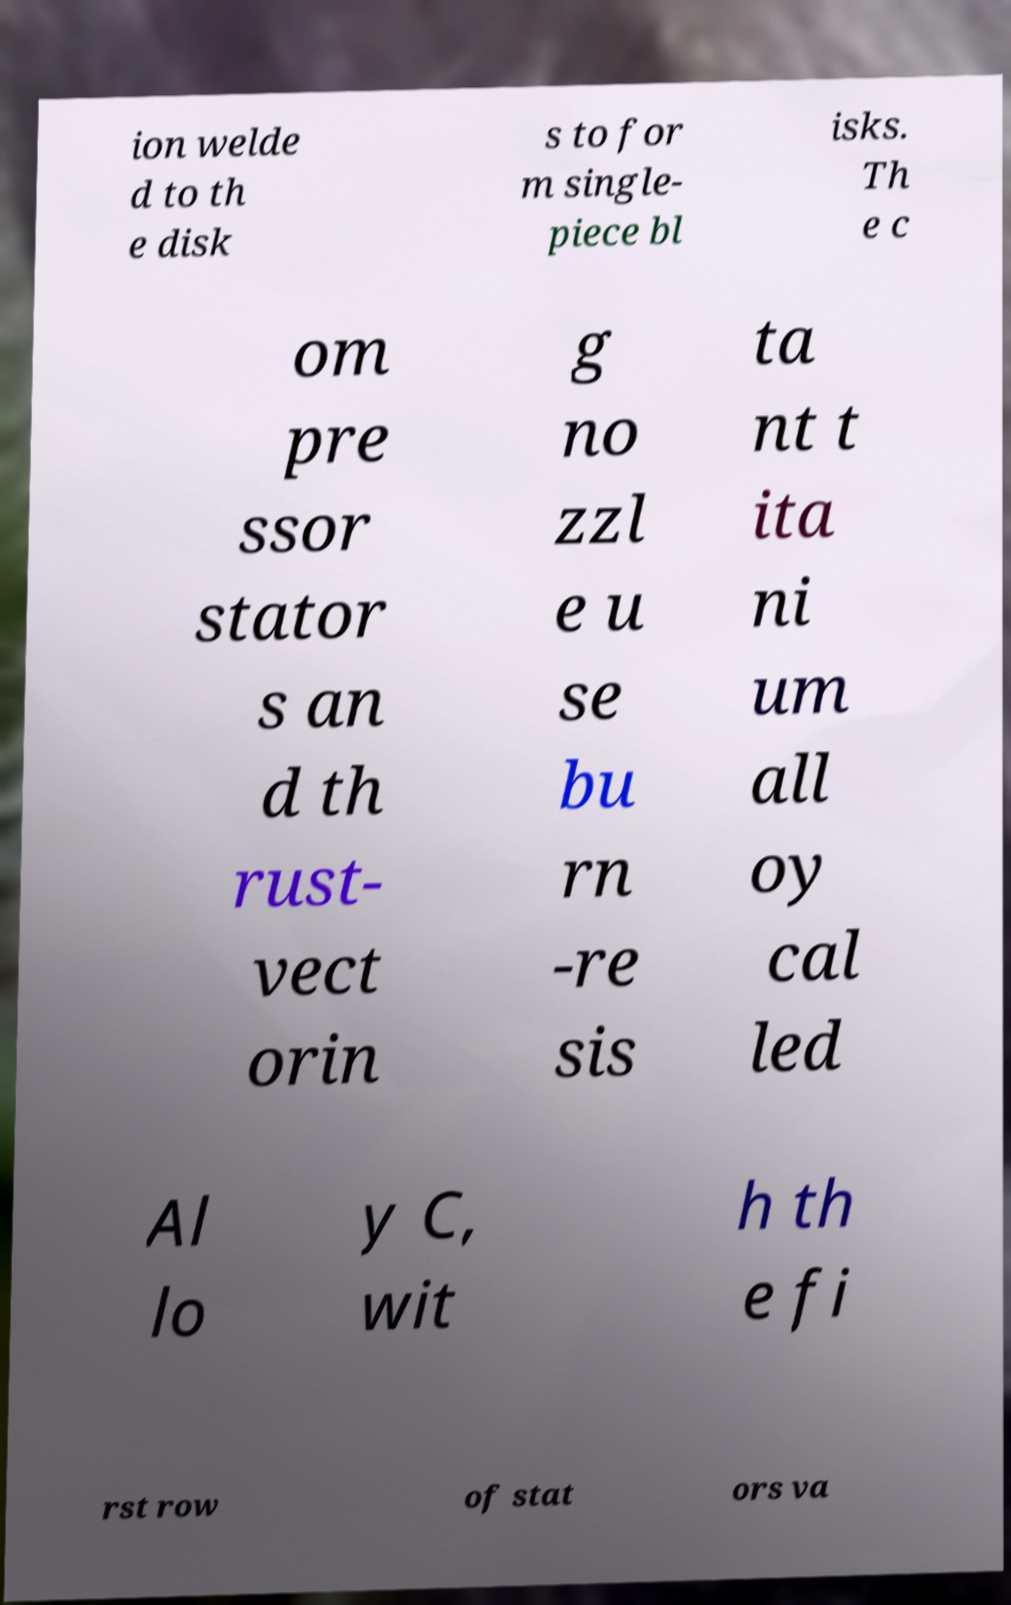Could you assist in decoding the text presented in this image and type it out clearly? ion welde d to th e disk s to for m single- piece bl isks. Th e c om pre ssor stator s an d th rust- vect orin g no zzl e u se bu rn -re sis ta nt t ita ni um all oy cal led Al lo y C, wit h th e fi rst row of stat ors va 